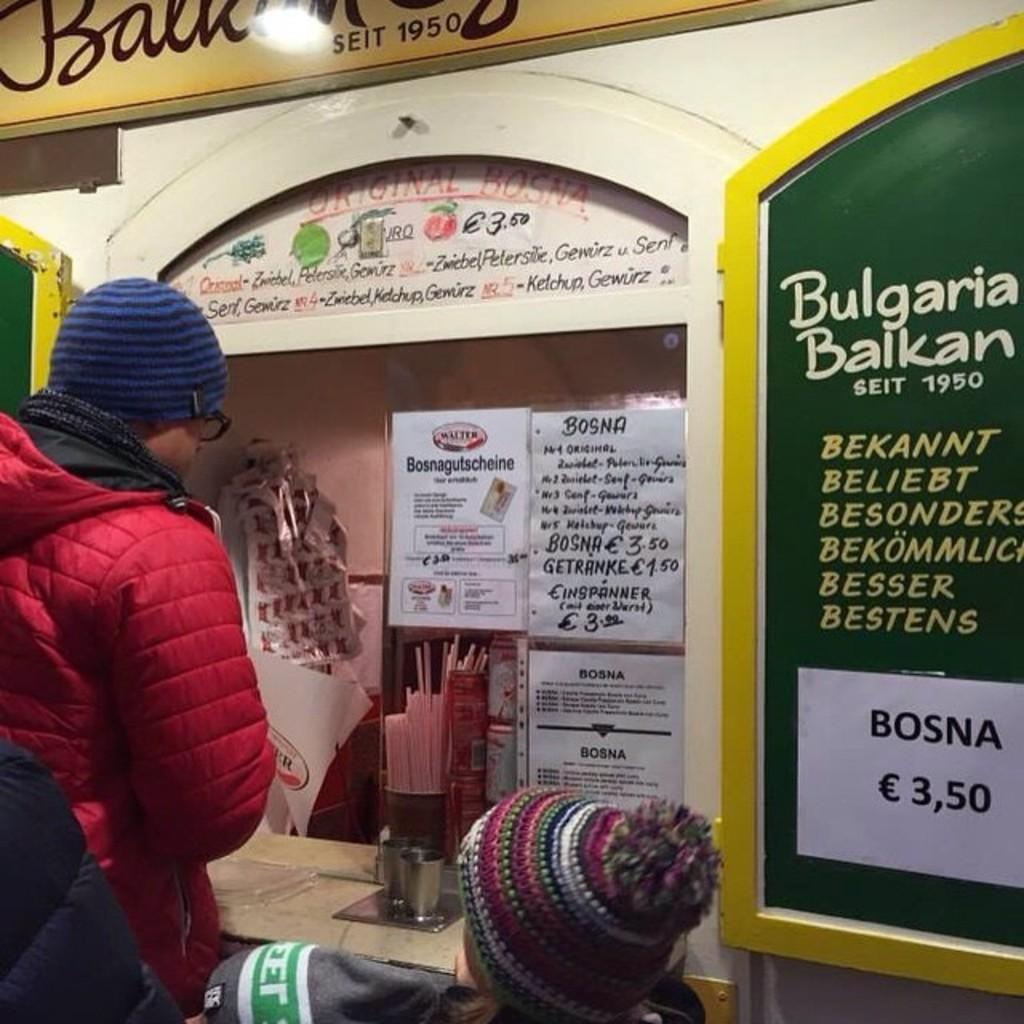Could you give a brief overview of what you see in this image? In this image I can see a person wearing red jacket and blue cap. In front I can see few pamphlet attached to the wall and something is written on it. The wall is white color. I can see a green and yellow color doors. 